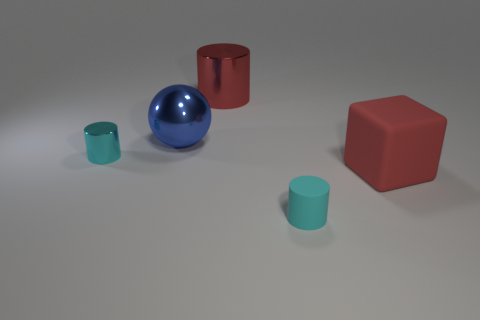Subtract all small cyan cylinders. How many cylinders are left? 1 Subtract all yellow balls. How many cyan cylinders are left? 2 Add 1 tiny red matte things. How many objects exist? 6 Subtract all cylinders. How many objects are left? 2 Subtract all red things. Subtract all balls. How many objects are left? 2 Add 1 rubber cylinders. How many rubber cylinders are left? 2 Add 2 tiny cyan metallic balls. How many tiny cyan metallic balls exist? 2 Subtract 0 yellow cylinders. How many objects are left? 5 Subtract all blue cylinders. Subtract all yellow blocks. How many cylinders are left? 3 